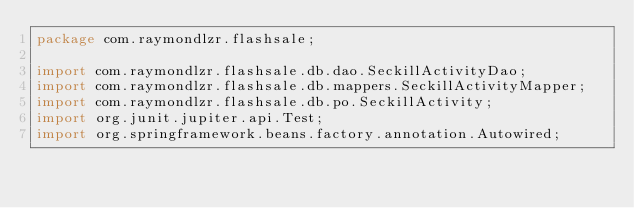<code> <loc_0><loc_0><loc_500><loc_500><_Java_>package com.raymondlzr.flashsale;

import com.raymondlzr.flashsale.db.dao.SeckillActivityDao;
import com.raymondlzr.flashsale.db.mappers.SeckillActivityMapper;
import com.raymondlzr.flashsale.db.po.SeckillActivity;
import org.junit.jupiter.api.Test;
import org.springframework.beans.factory.annotation.Autowired;</code> 